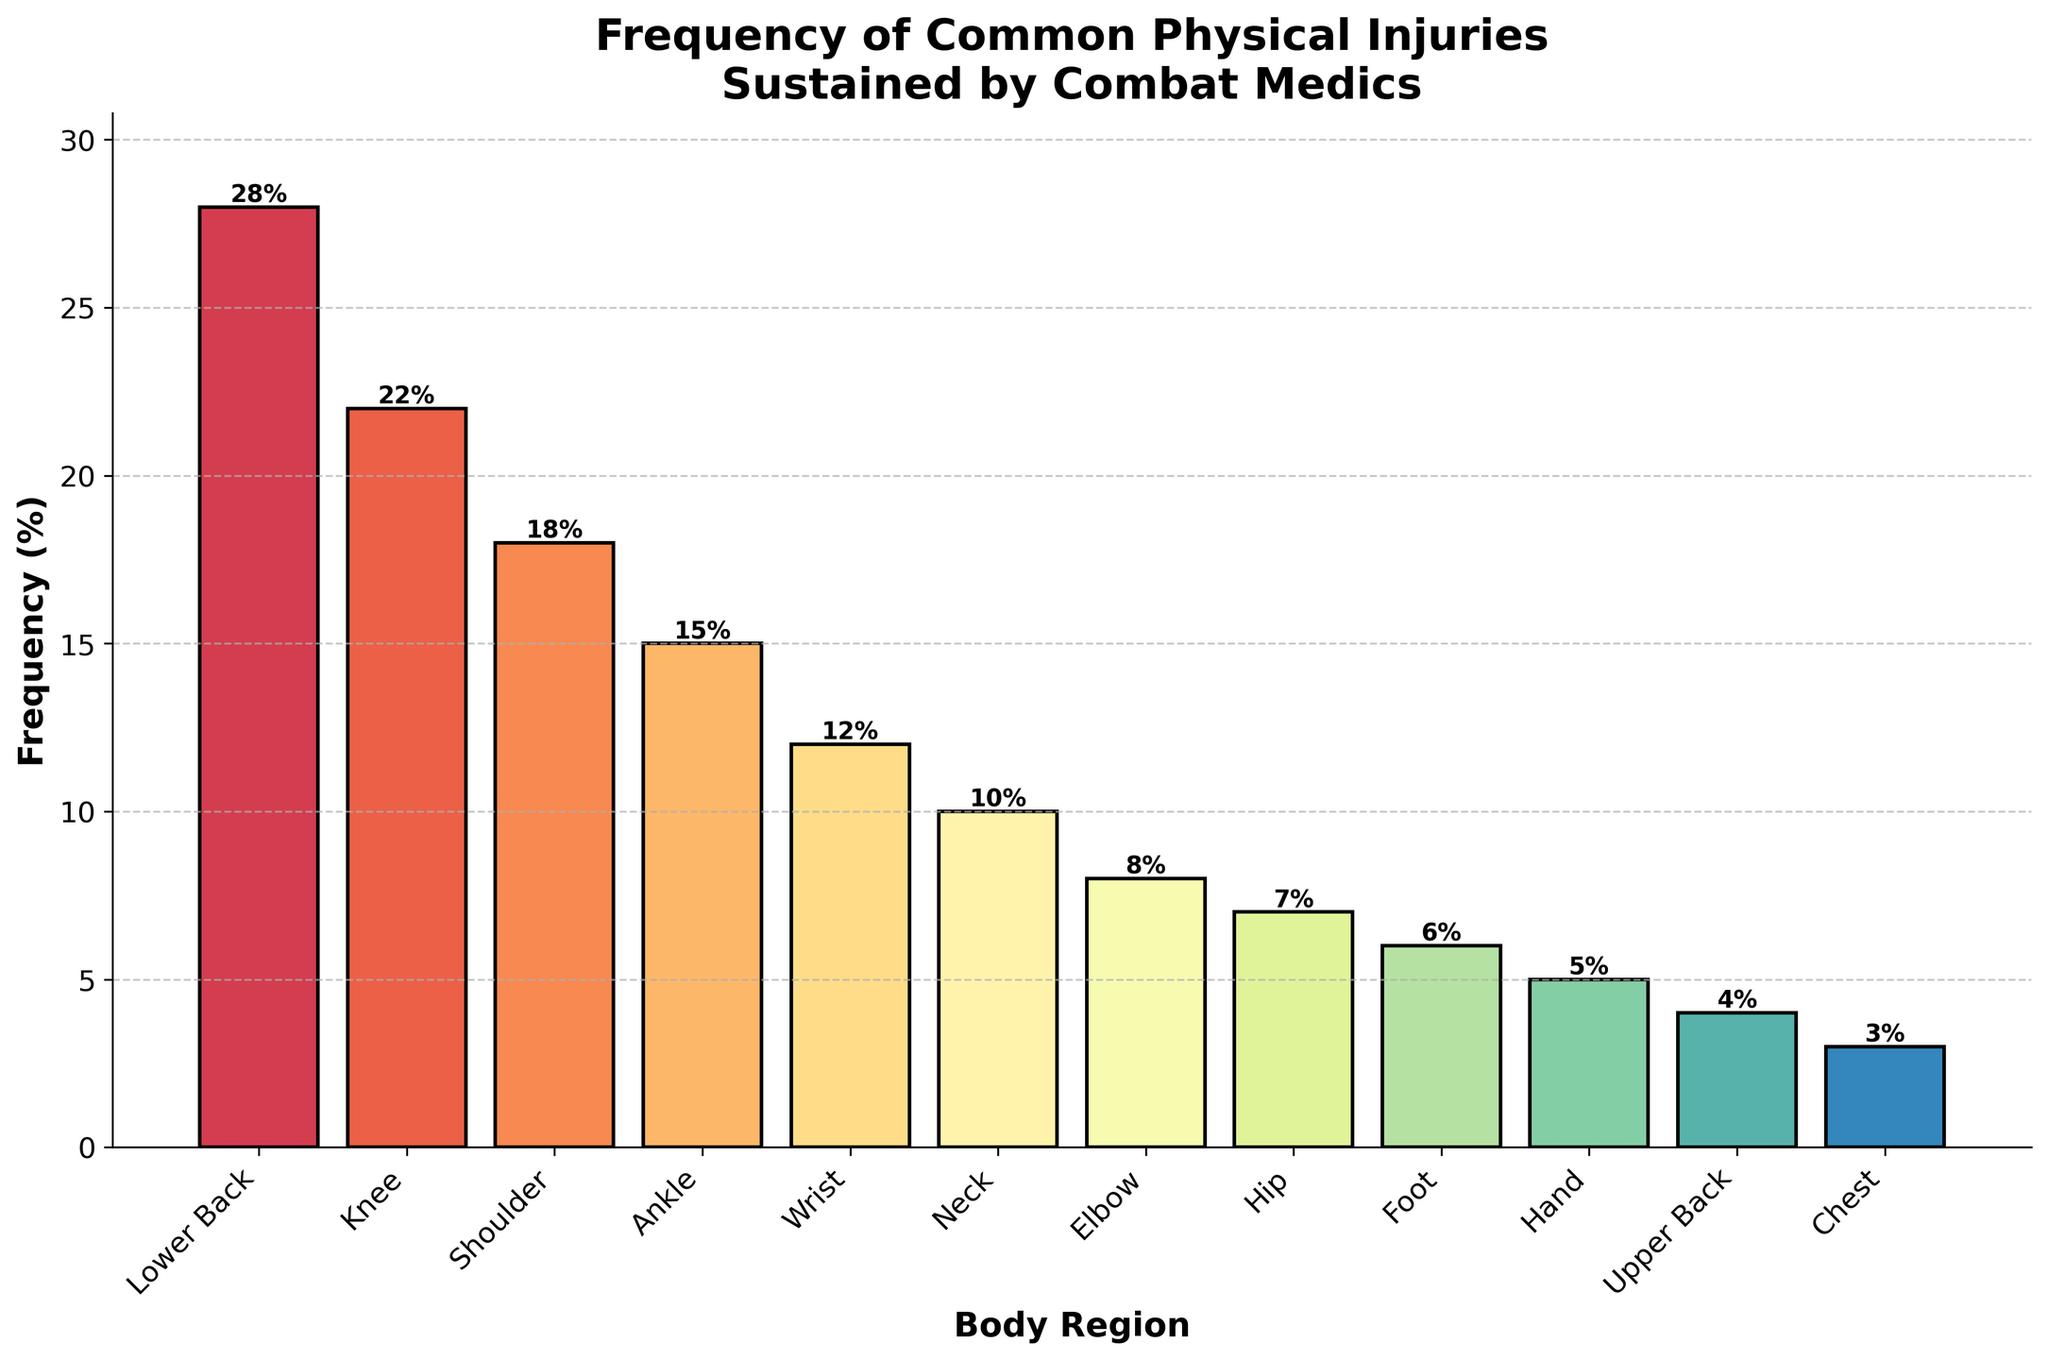Which body region has the highest frequency of injuries? The figure shows the frequency of injuries by body region. The bar representing the "Lower Back" is the tallest, indicating the highest frequency.
Answer: Lower Back Which body region has the lowest frequency of injuries? The figure shows the frequency of injuries by body region. The bar representing the "Chest" is the shortest, indicating the lowest frequency.
Answer: Chest Are knee injuries more common than shoulder injuries? To compare the knee and shoulder injuries, look at the height of their respective bars. The knee bar is slightly taller than the shoulder bar.
Answer: Yes What is the total frequency percentage of the top three most frequently injured body regions? The top three regions are "Lower Back" (28%), "Knee" (22%), and "Shoulder" (18%). Summing these gives: 28 + 22 + 18.
Answer: 68% Which body region has a frequency of injuries closest to 10%? The bars show neck injuries at 10%. This is the body region closest to 10%.
Answer: Neck Is the frequency of hand injuries greater than foot injuries? Look at the height of the bars for hand and foot. The foot bar is slightly taller than the hand bar.
Answer: No Combine the frequencies of shoulder and ankle injuries. How do they compare to the frequency of knee injuries alone? The frequency for shoulder is 18% and for ankle is 15%. Combined, this is 18 + 15 = 33%. This is more than the knee frequency, which is 22%.
Answer: 33% is greater than 22% What is the difference in injury frequency between the most and least frequently injured body regions? The highest frequency is "Lower Back" (28%) and the lowest is "Chest" (3%). Subtracting these gives: 28 - 3.
Answer: 25% How many body regions have a frequency of 10% or higher? The bars above 10% are for "Lower Back" (28%), "Knee" (22%), "Shoulder" (18%), "Ankle" (15%), and "Wrist" (12%). Counting these gives 5.
Answer: 5 Based on the visual colors used, what color represents injuries to the wrist? The color used in the figure for the wrist bar would be identified by matching it visually to others. According to the colormap's gradient, it is likely in a color around mid-spectrum.
Answer: Mid-spectrum color 